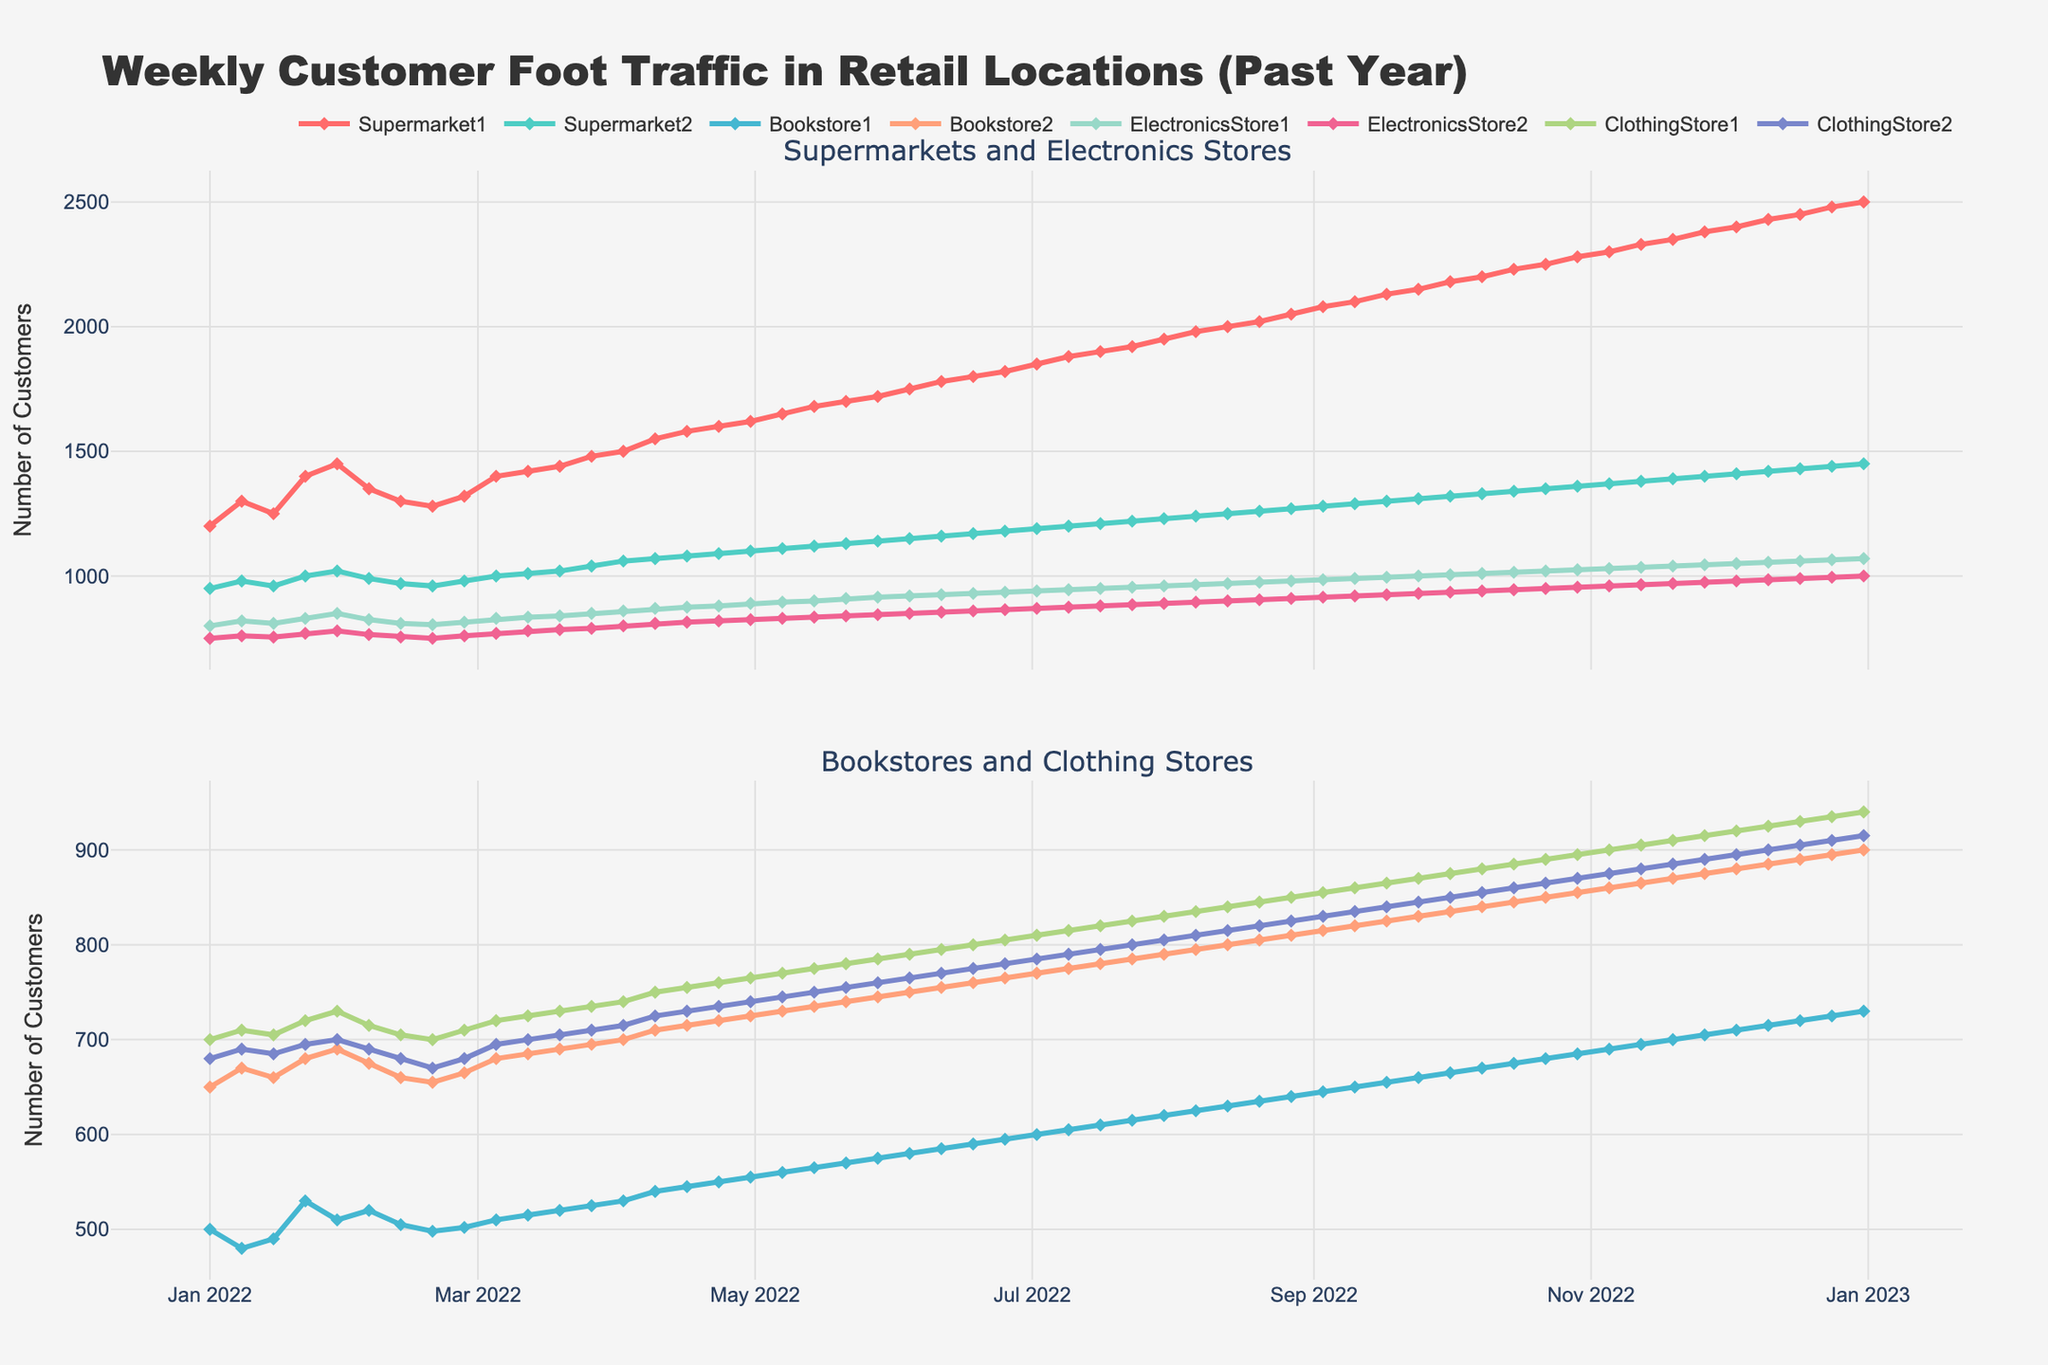What's the title of the figure? The title is prominently displayed at the top of the figure where it summarizes the purpose of the plot.
Answer: Weekly Customer Foot Traffic in Retail Locations (Past Year) How many subplots are there in the figure? The layout of the figure shows multiple sections, and a clear delimitation is made with separate titles for these sections.
Answer: 2 What is the trend in customer traffic for Supermarket1 over the past year? To determine the trend, we need to observe the line representing Supermarket1 from the start to the end date and see if it generally increases, decreases, or stays constant. The line consistently rises over time.
Answer: Increasing Which store had the lowest customer foot traffic at the start of the year? Look at the first date on the x-axis and compare the data points on that date for each store. Identify the lowest value.
Answer: Bookstore1 During which approximate month did ClothingStore1's customer traffic reach 800? Locate the point on the x-axis corresponding to the month and look for when the ClothingStore1 line crosses the 800 mark on the y-axis.
Answer: Early July What is the difference in customer traffic between Supermarket1 and Bookstore1 on June 1st? Find the values for Supermarket1 and Bookstore1 on the specified date, then calculate the difference between them.
Answer: 1200 How does the customer traffic of Bookstore2 compare to ElectronicsStore1 at the end of the year? Look at the data points for both Bookstore2 and ElectronicsStore1 on the last date of the x-axis and compare the two values.
Answer: ElectronicsStore1 has higher traffic What is the average weekly customer traffic for Supermarket2 in January 2022? Sum the customer traffic values for the four January dates for Supermarket2, then divide by 4 to get the average.
Answer: 977.5 Are there any significant seasonal variations observed in the customer traffic of ElectronicsStore2? Examine the peaks and troughs of the ElectronicsStore2 line throughout the year to see if there are periodic changes that correspond to seasons.
Answer: Yes, increasing towards the year-end 